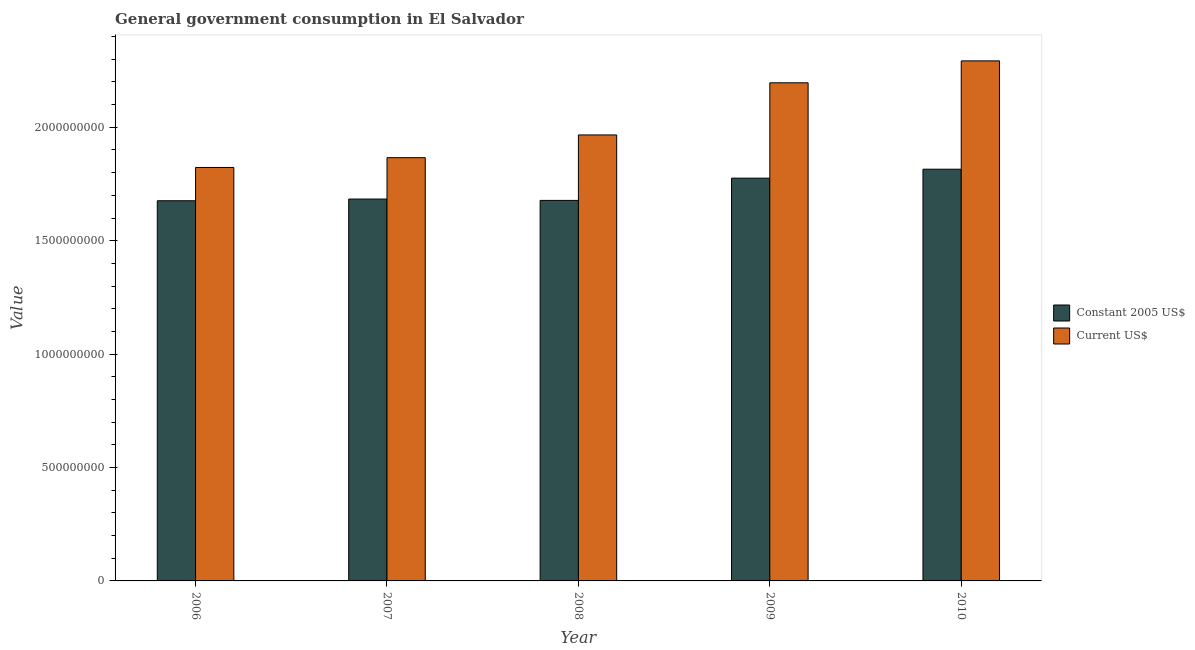How many different coloured bars are there?
Provide a short and direct response. 2. How many groups of bars are there?
Provide a succinct answer. 5. Are the number of bars on each tick of the X-axis equal?
Provide a short and direct response. Yes. How many bars are there on the 4th tick from the right?
Your answer should be compact. 2. In how many cases, is the number of bars for a given year not equal to the number of legend labels?
Your response must be concise. 0. What is the value consumed in constant 2005 us$ in 2007?
Your answer should be very brief. 1.68e+09. Across all years, what is the maximum value consumed in constant 2005 us$?
Ensure brevity in your answer.  1.82e+09. Across all years, what is the minimum value consumed in current us$?
Provide a short and direct response. 1.82e+09. In which year was the value consumed in constant 2005 us$ minimum?
Make the answer very short. 2006. What is the total value consumed in constant 2005 us$ in the graph?
Provide a short and direct response. 8.63e+09. What is the difference between the value consumed in constant 2005 us$ in 2009 and that in 2010?
Offer a very short reply. -3.95e+07. What is the difference between the value consumed in current us$ in 2010 and the value consumed in constant 2005 us$ in 2007?
Offer a terse response. 4.27e+08. What is the average value consumed in constant 2005 us$ per year?
Offer a very short reply. 1.73e+09. In the year 2007, what is the difference between the value consumed in current us$ and value consumed in constant 2005 us$?
Offer a very short reply. 0. In how many years, is the value consumed in constant 2005 us$ greater than 1100000000?
Make the answer very short. 5. What is the ratio of the value consumed in current us$ in 2007 to that in 2010?
Ensure brevity in your answer.  0.81. Is the difference between the value consumed in constant 2005 us$ in 2006 and 2009 greater than the difference between the value consumed in current us$ in 2006 and 2009?
Keep it short and to the point. No. What is the difference between the highest and the second highest value consumed in current us$?
Provide a succinct answer. 9.67e+07. What is the difference between the highest and the lowest value consumed in current us$?
Your answer should be very brief. 4.70e+08. In how many years, is the value consumed in current us$ greater than the average value consumed in current us$ taken over all years?
Make the answer very short. 2. Is the sum of the value consumed in current us$ in 2007 and 2008 greater than the maximum value consumed in constant 2005 us$ across all years?
Keep it short and to the point. Yes. What does the 1st bar from the left in 2008 represents?
Provide a succinct answer. Constant 2005 US$. What does the 1st bar from the right in 2007 represents?
Offer a terse response. Current US$. How many bars are there?
Give a very brief answer. 10. What is the difference between two consecutive major ticks on the Y-axis?
Your answer should be compact. 5.00e+08. Are the values on the major ticks of Y-axis written in scientific E-notation?
Your response must be concise. No. Does the graph contain grids?
Make the answer very short. No. Where does the legend appear in the graph?
Offer a very short reply. Center right. How many legend labels are there?
Your answer should be compact. 2. What is the title of the graph?
Your answer should be very brief. General government consumption in El Salvador. Does "UN agencies" appear as one of the legend labels in the graph?
Keep it short and to the point. No. What is the label or title of the Y-axis?
Give a very brief answer. Value. What is the Value in Constant 2005 US$ in 2006?
Provide a succinct answer. 1.68e+09. What is the Value in Current US$ in 2006?
Ensure brevity in your answer.  1.82e+09. What is the Value of Constant 2005 US$ in 2007?
Provide a succinct answer. 1.68e+09. What is the Value in Current US$ in 2007?
Your answer should be very brief. 1.87e+09. What is the Value of Constant 2005 US$ in 2008?
Your answer should be compact. 1.68e+09. What is the Value in Current US$ in 2008?
Ensure brevity in your answer.  1.97e+09. What is the Value in Constant 2005 US$ in 2009?
Offer a very short reply. 1.78e+09. What is the Value in Current US$ in 2009?
Provide a succinct answer. 2.20e+09. What is the Value of Constant 2005 US$ in 2010?
Offer a very short reply. 1.82e+09. What is the Value in Current US$ in 2010?
Provide a short and direct response. 2.29e+09. Across all years, what is the maximum Value of Constant 2005 US$?
Make the answer very short. 1.82e+09. Across all years, what is the maximum Value in Current US$?
Your answer should be very brief. 2.29e+09. Across all years, what is the minimum Value in Constant 2005 US$?
Provide a succinct answer. 1.68e+09. Across all years, what is the minimum Value of Current US$?
Your answer should be very brief. 1.82e+09. What is the total Value of Constant 2005 US$ in the graph?
Ensure brevity in your answer.  8.63e+09. What is the total Value in Current US$ in the graph?
Keep it short and to the point. 1.01e+1. What is the difference between the Value in Constant 2005 US$ in 2006 and that in 2007?
Give a very brief answer. -7.49e+06. What is the difference between the Value in Current US$ in 2006 and that in 2007?
Your answer should be compact. -4.32e+07. What is the difference between the Value in Constant 2005 US$ in 2006 and that in 2008?
Make the answer very short. -1.50e+06. What is the difference between the Value of Current US$ in 2006 and that in 2008?
Offer a terse response. -1.43e+08. What is the difference between the Value in Constant 2005 US$ in 2006 and that in 2009?
Provide a short and direct response. -9.96e+07. What is the difference between the Value in Current US$ in 2006 and that in 2009?
Your answer should be compact. -3.73e+08. What is the difference between the Value in Constant 2005 US$ in 2006 and that in 2010?
Your answer should be compact. -1.39e+08. What is the difference between the Value of Current US$ in 2006 and that in 2010?
Provide a succinct answer. -4.70e+08. What is the difference between the Value in Constant 2005 US$ in 2007 and that in 2008?
Your answer should be very brief. 5.99e+06. What is the difference between the Value in Current US$ in 2007 and that in 2008?
Give a very brief answer. -1.00e+08. What is the difference between the Value of Constant 2005 US$ in 2007 and that in 2009?
Your answer should be compact. -9.21e+07. What is the difference between the Value of Current US$ in 2007 and that in 2009?
Offer a very short reply. -3.30e+08. What is the difference between the Value of Constant 2005 US$ in 2007 and that in 2010?
Give a very brief answer. -1.32e+08. What is the difference between the Value in Current US$ in 2007 and that in 2010?
Offer a terse response. -4.27e+08. What is the difference between the Value in Constant 2005 US$ in 2008 and that in 2009?
Give a very brief answer. -9.81e+07. What is the difference between the Value of Current US$ in 2008 and that in 2009?
Your answer should be very brief. -2.30e+08. What is the difference between the Value in Constant 2005 US$ in 2008 and that in 2010?
Ensure brevity in your answer.  -1.38e+08. What is the difference between the Value of Current US$ in 2008 and that in 2010?
Keep it short and to the point. -3.26e+08. What is the difference between the Value of Constant 2005 US$ in 2009 and that in 2010?
Ensure brevity in your answer.  -3.95e+07. What is the difference between the Value of Current US$ in 2009 and that in 2010?
Make the answer very short. -9.67e+07. What is the difference between the Value in Constant 2005 US$ in 2006 and the Value in Current US$ in 2007?
Give a very brief answer. -1.90e+08. What is the difference between the Value of Constant 2005 US$ in 2006 and the Value of Current US$ in 2008?
Give a very brief answer. -2.90e+08. What is the difference between the Value in Constant 2005 US$ in 2006 and the Value in Current US$ in 2009?
Your answer should be compact. -5.20e+08. What is the difference between the Value of Constant 2005 US$ in 2006 and the Value of Current US$ in 2010?
Make the answer very short. -6.17e+08. What is the difference between the Value of Constant 2005 US$ in 2007 and the Value of Current US$ in 2008?
Your answer should be very brief. -2.83e+08. What is the difference between the Value in Constant 2005 US$ in 2007 and the Value in Current US$ in 2009?
Give a very brief answer. -5.12e+08. What is the difference between the Value in Constant 2005 US$ in 2007 and the Value in Current US$ in 2010?
Your response must be concise. -6.09e+08. What is the difference between the Value in Constant 2005 US$ in 2008 and the Value in Current US$ in 2009?
Keep it short and to the point. -5.18e+08. What is the difference between the Value of Constant 2005 US$ in 2008 and the Value of Current US$ in 2010?
Ensure brevity in your answer.  -6.15e+08. What is the difference between the Value in Constant 2005 US$ in 2009 and the Value in Current US$ in 2010?
Provide a short and direct response. -5.17e+08. What is the average Value of Constant 2005 US$ per year?
Your answer should be compact. 1.73e+09. What is the average Value in Current US$ per year?
Offer a terse response. 2.03e+09. In the year 2006, what is the difference between the Value of Constant 2005 US$ and Value of Current US$?
Ensure brevity in your answer.  -1.47e+08. In the year 2007, what is the difference between the Value of Constant 2005 US$ and Value of Current US$?
Make the answer very short. -1.82e+08. In the year 2008, what is the difference between the Value of Constant 2005 US$ and Value of Current US$?
Your answer should be very brief. -2.89e+08. In the year 2009, what is the difference between the Value in Constant 2005 US$ and Value in Current US$?
Keep it short and to the point. -4.20e+08. In the year 2010, what is the difference between the Value of Constant 2005 US$ and Value of Current US$?
Your response must be concise. -4.78e+08. What is the ratio of the Value of Constant 2005 US$ in 2006 to that in 2007?
Provide a short and direct response. 1. What is the ratio of the Value in Current US$ in 2006 to that in 2007?
Give a very brief answer. 0.98. What is the ratio of the Value in Constant 2005 US$ in 2006 to that in 2008?
Make the answer very short. 1. What is the ratio of the Value in Current US$ in 2006 to that in 2008?
Your answer should be compact. 0.93. What is the ratio of the Value in Constant 2005 US$ in 2006 to that in 2009?
Provide a succinct answer. 0.94. What is the ratio of the Value in Current US$ in 2006 to that in 2009?
Give a very brief answer. 0.83. What is the ratio of the Value of Constant 2005 US$ in 2006 to that in 2010?
Offer a very short reply. 0.92. What is the ratio of the Value in Current US$ in 2006 to that in 2010?
Your answer should be very brief. 0.8. What is the ratio of the Value of Constant 2005 US$ in 2007 to that in 2008?
Offer a terse response. 1. What is the ratio of the Value in Current US$ in 2007 to that in 2008?
Offer a terse response. 0.95. What is the ratio of the Value of Constant 2005 US$ in 2007 to that in 2009?
Provide a succinct answer. 0.95. What is the ratio of the Value of Current US$ in 2007 to that in 2009?
Your response must be concise. 0.85. What is the ratio of the Value of Constant 2005 US$ in 2007 to that in 2010?
Your answer should be very brief. 0.93. What is the ratio of the Value of Current US$ in 2007 to that in 2010?
Your answer should be very brief. 0.81. What is the ratio of the Value in Constant 2005 US$ in 2008 to that in 2009?
Your answer should be very brief. 0.94. What is the ratio of the Value of Current US$ in 2008 to that in 2009?
Offer a very short reply. 0.9. What is the ratio of the Value of Constant 2005 US$ in 2008 to that in 2010?
Ensure brevity in your answer.  0.92. What is the ratio of the Value of Current US$ in 2008 to that in 2010?
Ensure brevity in your answer.  0.86. What is the ratio of the Value in Constant 2005 US$ in 2009 to that in 2010?
Your answer should be very brief. 0.98. What is the ratio of the Value in Current US$ in 2009 to that in 2010?
Give a very brief answer. 0.96. What is the difference between the highest and the second highest Value of Constant 2005 US$?
Ensure brevity in your answer.  3.95e+07. What is the difference between the highest and the second highest Value in Current US$?
Provide a short and direct response. 9.67e+07. What is the difference between the highest and the lowest Value of Constant 2005 US$?
Make the answer very short. 1.39e+08. What is the difference between the highest and the lowest Value of Current US$?
Provide a succinct answer. 4.70e+08. 